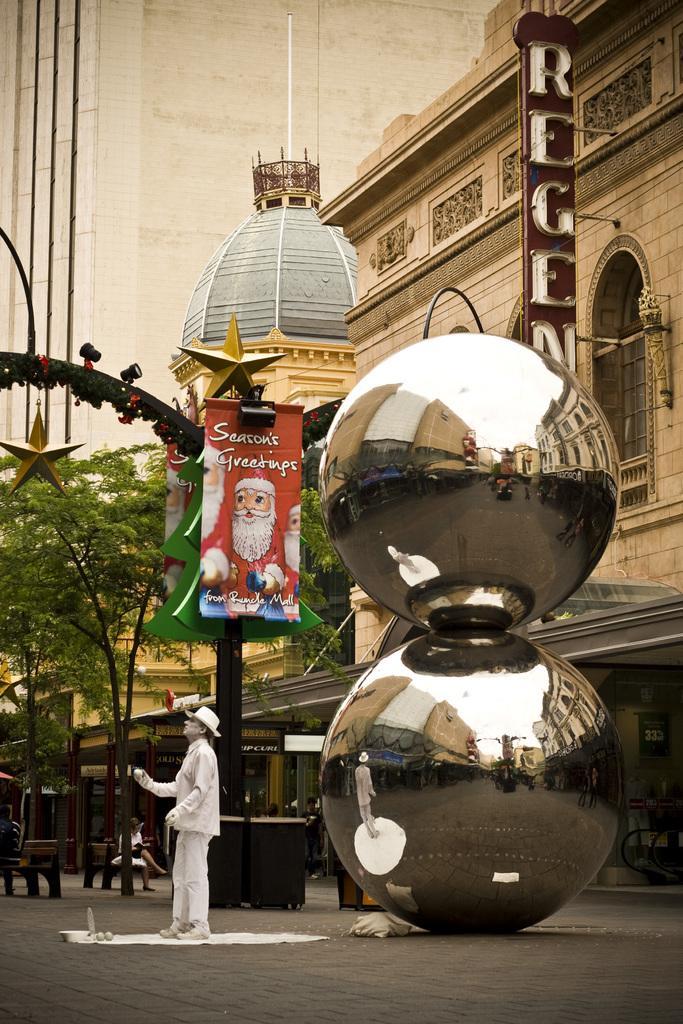Please provide a concise description of this image. In the image we can see a sculpture of a person standing, wearing clothes, shoes, gloves and a cap. These are the decorative balls, footpath, bench, trees, pole, banner, building and a text. 